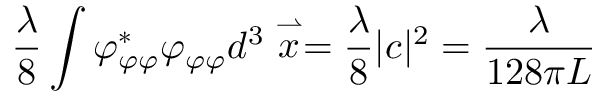Convert formula to latex. <formula><loc_0><loc_0><loc_500><loc_500>\frac { \lambda } { 8 } \int \varphi _ { \varphi \varphi } ^ { * } \varphi _ { \varphi \varphi } d ^ { 3 } \stackrel { \rightharpoonup } { x } = \frac { \lambda } { 8 } | c | ^ { 2 } = \frac { \lambda } { 1 2 8 \pi L }</formula> 